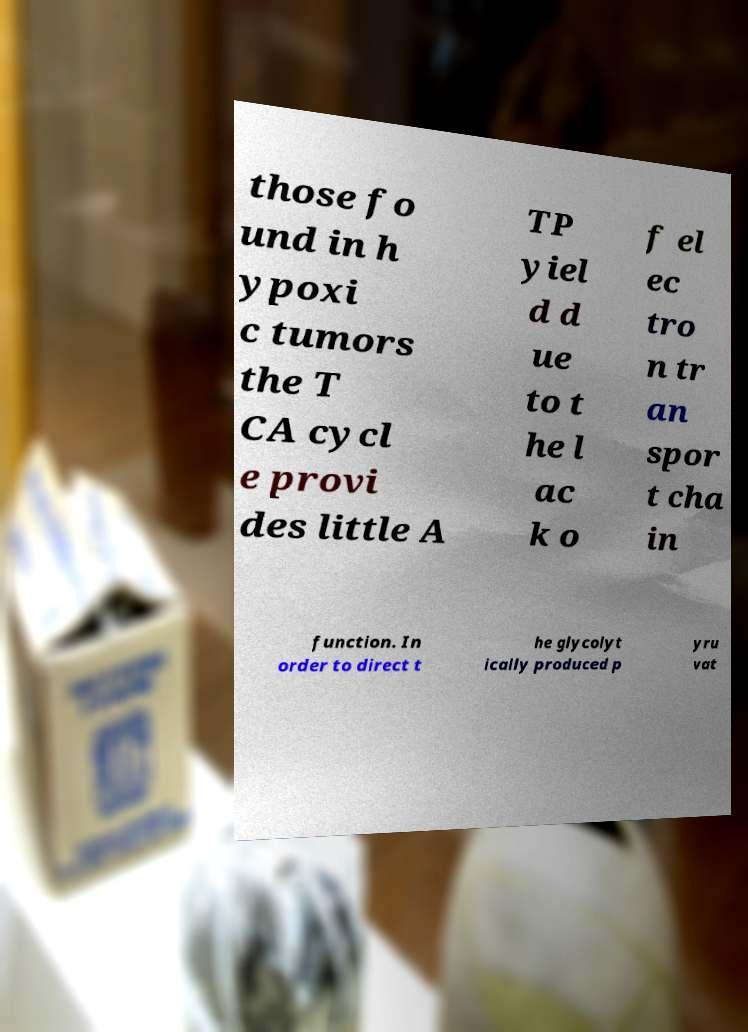Could you extract and type out the text from this image? those fo und in h ypoxi c tumors the T CA cycl e provi des little A TP yiel d d ue to t he l ac k o f el ec tro n tr an spor t cha in function. In order to direct t he glycolyt ically produced p yru vat 